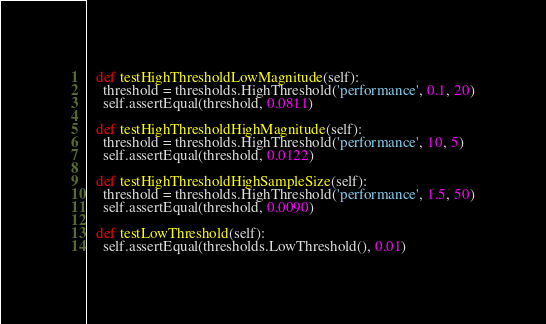Convert code to text. <code><loc_0><loc_0><loc_500><loc_500><_Python_>  def testHighThresholdLowMagnitude(self):
    threshold = thresholds.HighThreshold('performance', 0.1, 20)
    self.assertEqual(threshold, 0.0811)

  def testHighThresholdHighMagnitude(self):
    threshold = thresholds.HighThreshold('performance', 10, 5)
    self.assertEqual(threshold, 0.0122)

  def testHighThresholdHighSampleSize(self):
    threshold = thresholds.HighThreshold('performance', 1.5, 50)
    self.assertEqual(threshold, 0.0090)

  def testLowThreshold(self):
    self.assertEqual(thresholds.LowThreshold(), 0.01)
</code> 